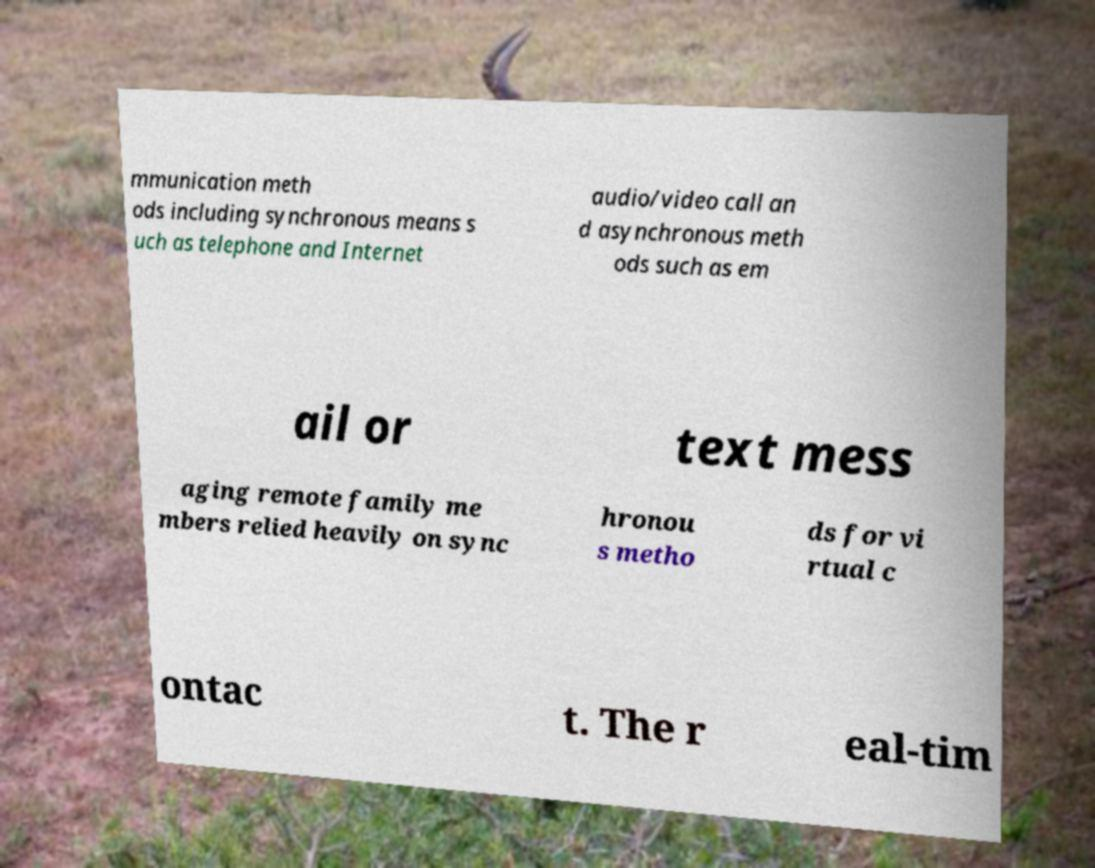Can you accurately transcribe the text from the provided image for me? mmunication meth ods including synchronous means s uch as telephone and Internet audio/video call an d asynchronous meth ods such as em ail or text mess aging remote family me mbers relied heavily on sync hronou s metho ds for vi rtual c ontac t. The r eal-tim 